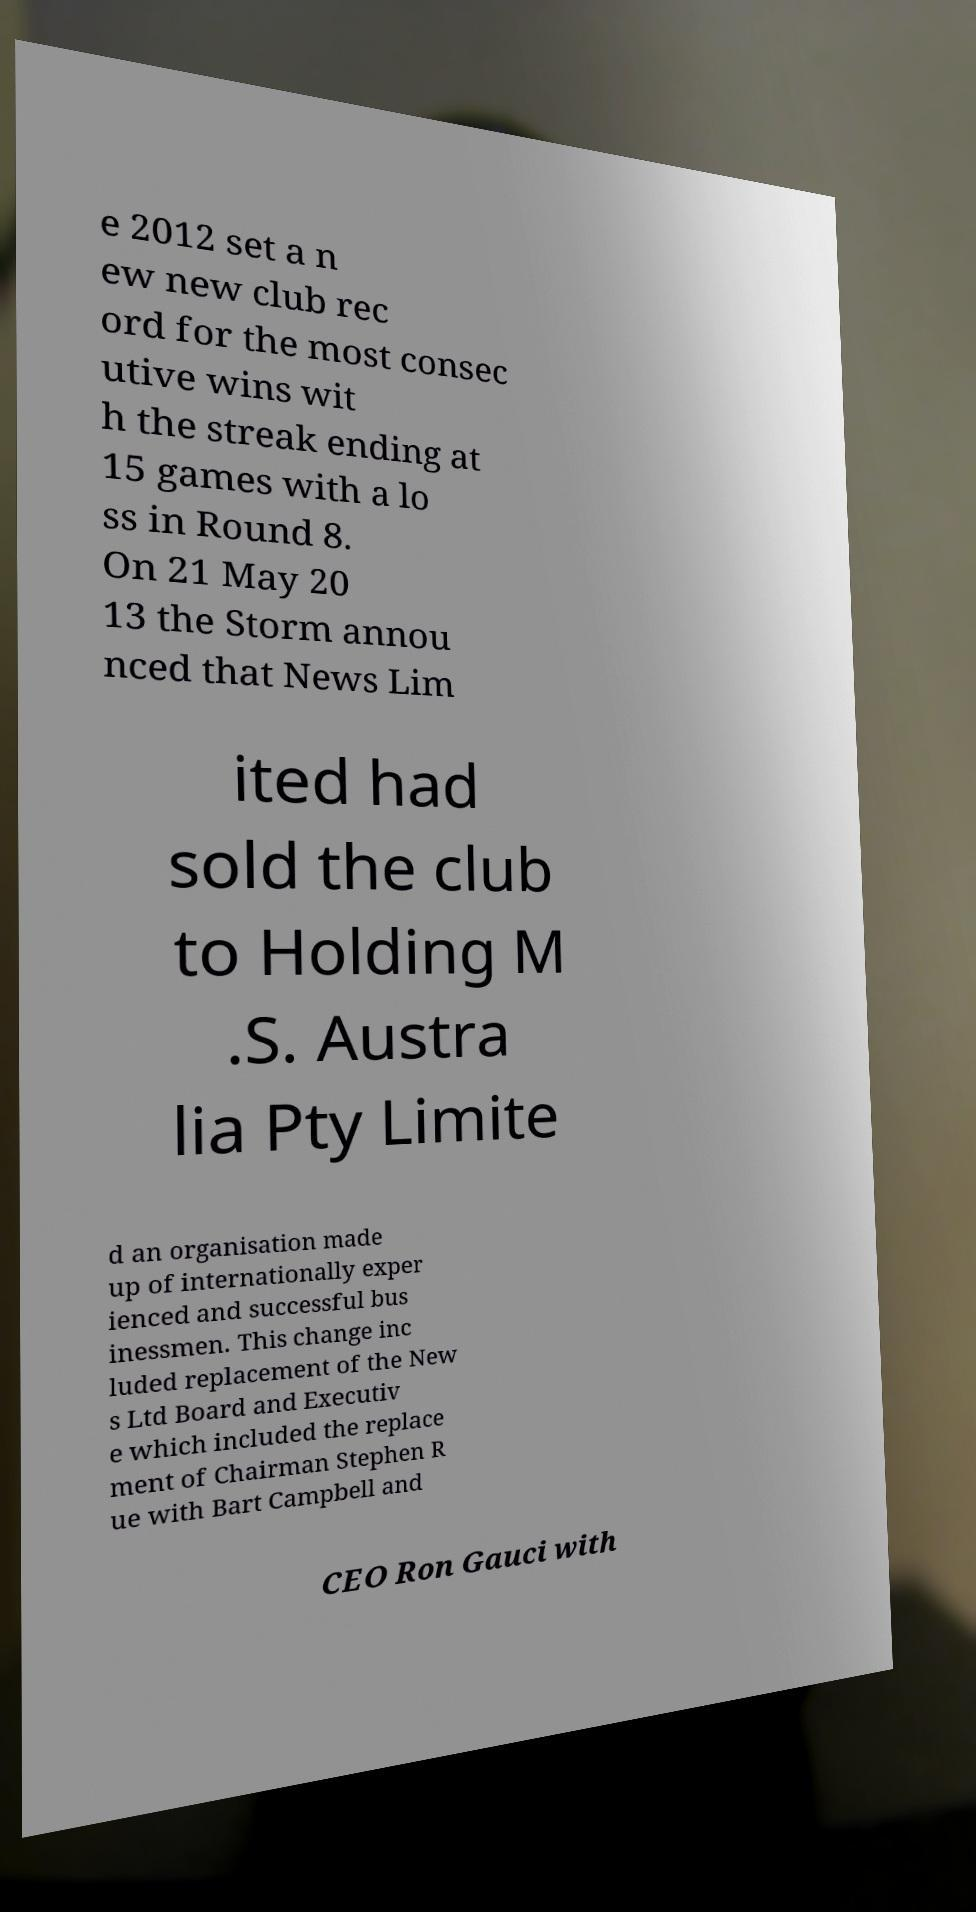Please read and relay the text visible in this image. What does it say? e 2012 set a n ew new club rec ord for the most consec utive wins wit h the streak ending at 15 games with a lo ss in Round 8. On 21 May 20 13 the Storm annou nced that News Lim ited had sold the club to Holding M .S. Austra lia Pty Limite d an organisation made up of internationally exper ienced and successful bus inessmen. This change inc luded replacement of the New s Ltd Board and Executiv e which included the replace ment of Chairman Stephen R ue with Bart Campbell and CEO Ron Gauci with 